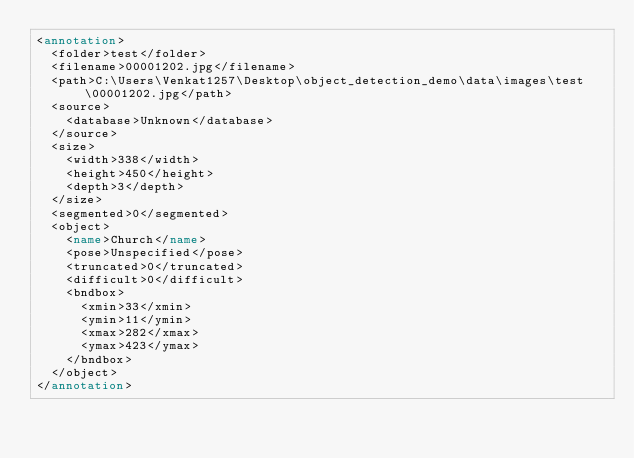<code> <loc_0><loc_0><loc_500><loc_500><_XML_><annotation>
	<folder>test</folder>
	<filename>00001202.jpg</filename>
	<path>C:\Users\Venkat1257\Desktop\object_detection_demo\data\images\test\00001202.jpg</path>
	<source>
		<database>Unknown</database>
	</source>
	<size>
		<width>338</width>
		<height>450</height>
		<depth>3</depth>
	</size>
	<segmented>0</segmented>
	<object>
		<name>Church</name>
		<pose>Unspecified</pose>
		<truncated>0</truncated>
		<difficult>0</difficult>
		<bndbox>
			<xmin>33</xmin>
			<ymin>11</ymin>
			<xmax>282</xmax>
			<ymax>423</ymax>
		</bndbox>
	</object>
</annotation>
</code> 